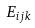<formula> <loc_0><loc_0><loc_500><loc_500>E _ { i j k }</formula> 